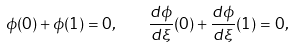<formula> <loc_0><loc_0><loc_500><loc_500>\phi ( 0 ) + \phi ( 1 ) = 0 , \quad \frac { d \phi } { d \xi } ( 0 ) + \frac { d \phi } { d \xi } ( 1 ) = 0 ,</formula> 